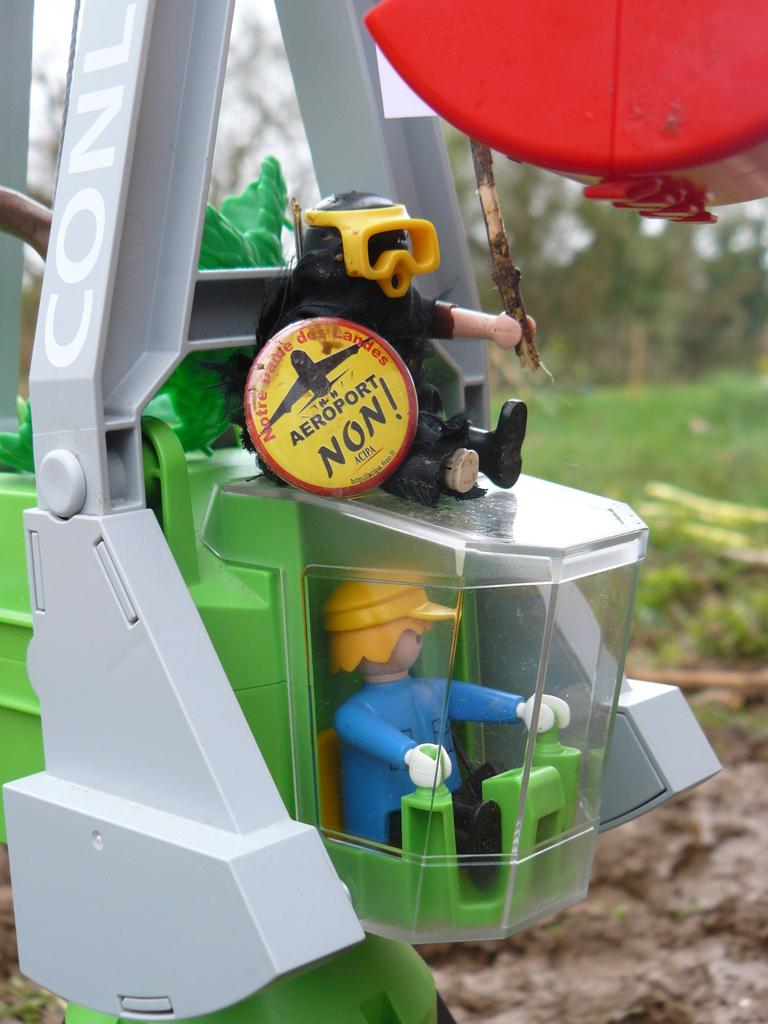What is the main subject in the center of the image? There is a toy in the center of the image. What can be seen in the background of the image? There are trees, grass, and the sky visible in the background of the image. What type of pencil is the lawyer using in the image? There is no lawyer or pencil present in the image. How many elbows can be seen in the image? There are no elbows visible in the image. 